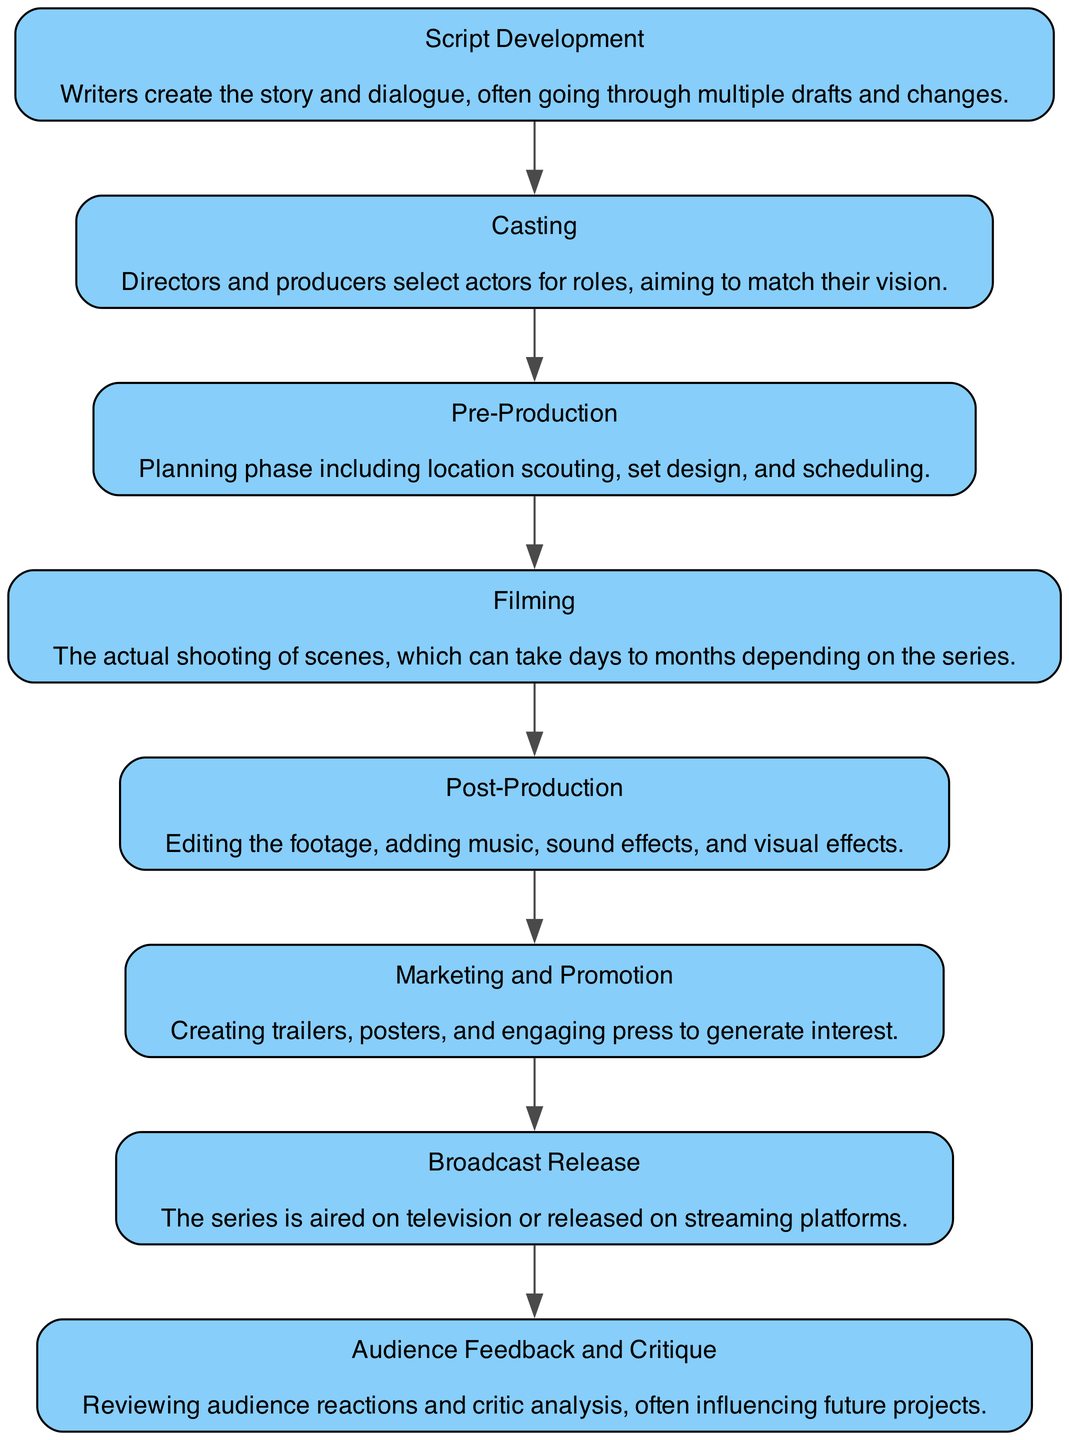What is the first step in the workflow? The first step in the workflow is represented as the first node in the flowchart, which is "Script Development."
Answer: Script Development How many total steps are there in the British drama series production workflow? By counting the nodes depicted in the flowchart, there are 8 distinct steps listed.
Answer: 8 What comes after Casting? Following the "Casting" node in the flowchart, the next step is "Pre-Production."
Answer: Pre-Production Which step deals with editing the footage? The "Post-Production" step focuses on the editing of the footage, along with adding music and effects.
Answer: Post-Production What is the final stage before the series is aired? The last process depicted before broadcast release is "Marketing and Promotion," which generates interest through trailers and posters.
Answer: Marketing and Promotion What steps are involved between Filming and Broadcast Release? Between the "Filming" and "Broadcast Release," the workflow proceeds through "Post-Production" and "Marketing and Promotion."
Answer: Post-Production and Marketing and Promotion Which phase includes location scouting? The phase that encompasses location scouting is "Pre-Production," where planning occurs prior to filming.
Answer: Pre-Production What feedback influences future projects? The "Audience Feedback and Critique" step provides insights from the audience, which can affect the direction of future productions.
Answer: Audience Feedback and Critique 